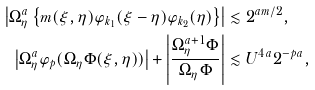<formula> <loc_0><loc_0><loc_500><loc_500>\left | \Omega ^ { a } _ { \eta } \left \{ m ( \xi , \eta ) \varphi _ { k _ { 1 } } ( \xi - \eta ) \varphi _ { k _ { 2 } } ( \eta ) \right \} \right | & \lesssim 2 ^ { a m / 2 } , \\ \left | \Omega ^ { a } _ { \eta } \varphi _ { p } ( \Omega _ { \eta } \Phi ( \xi , \eta ) ) \right | + \left | \frac { \Omega ^ { a + 1 } _ { \eta } \Phi } { \Omega _ { \eta } \Phi } \right | & \lesssim U ^ { 4 a } 2 ^ { - p a } , \\</formula> 